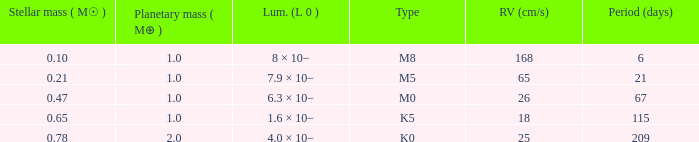I'm looking to parse the entire table for insights. Could you assist me with that? {'header': ['Stellar mass ( M☉ )', 'Planetary mass ( M⊕ )', 'Lum. (L 0 )', 'Type', 'RV (cm/s)', 'Period (days)'], 'rows': [['0.10', '1.0', '8 × 10−', 'M8', '168', '6'], ['0.21', '1.0', '7.9 × 10−', 'M5', '65', '21'], ['0.47', '1.0', '6.3 × 10−', 'M0', '26', '67'], ['0.65', '1.0', '1.6 × 10−', 'K5', '18', '115'], ['0.78', '2.0', '4.0 × 10−', 'K0', '25', '209']]} What is the overall stellar mass of the type m0? 0.47. 